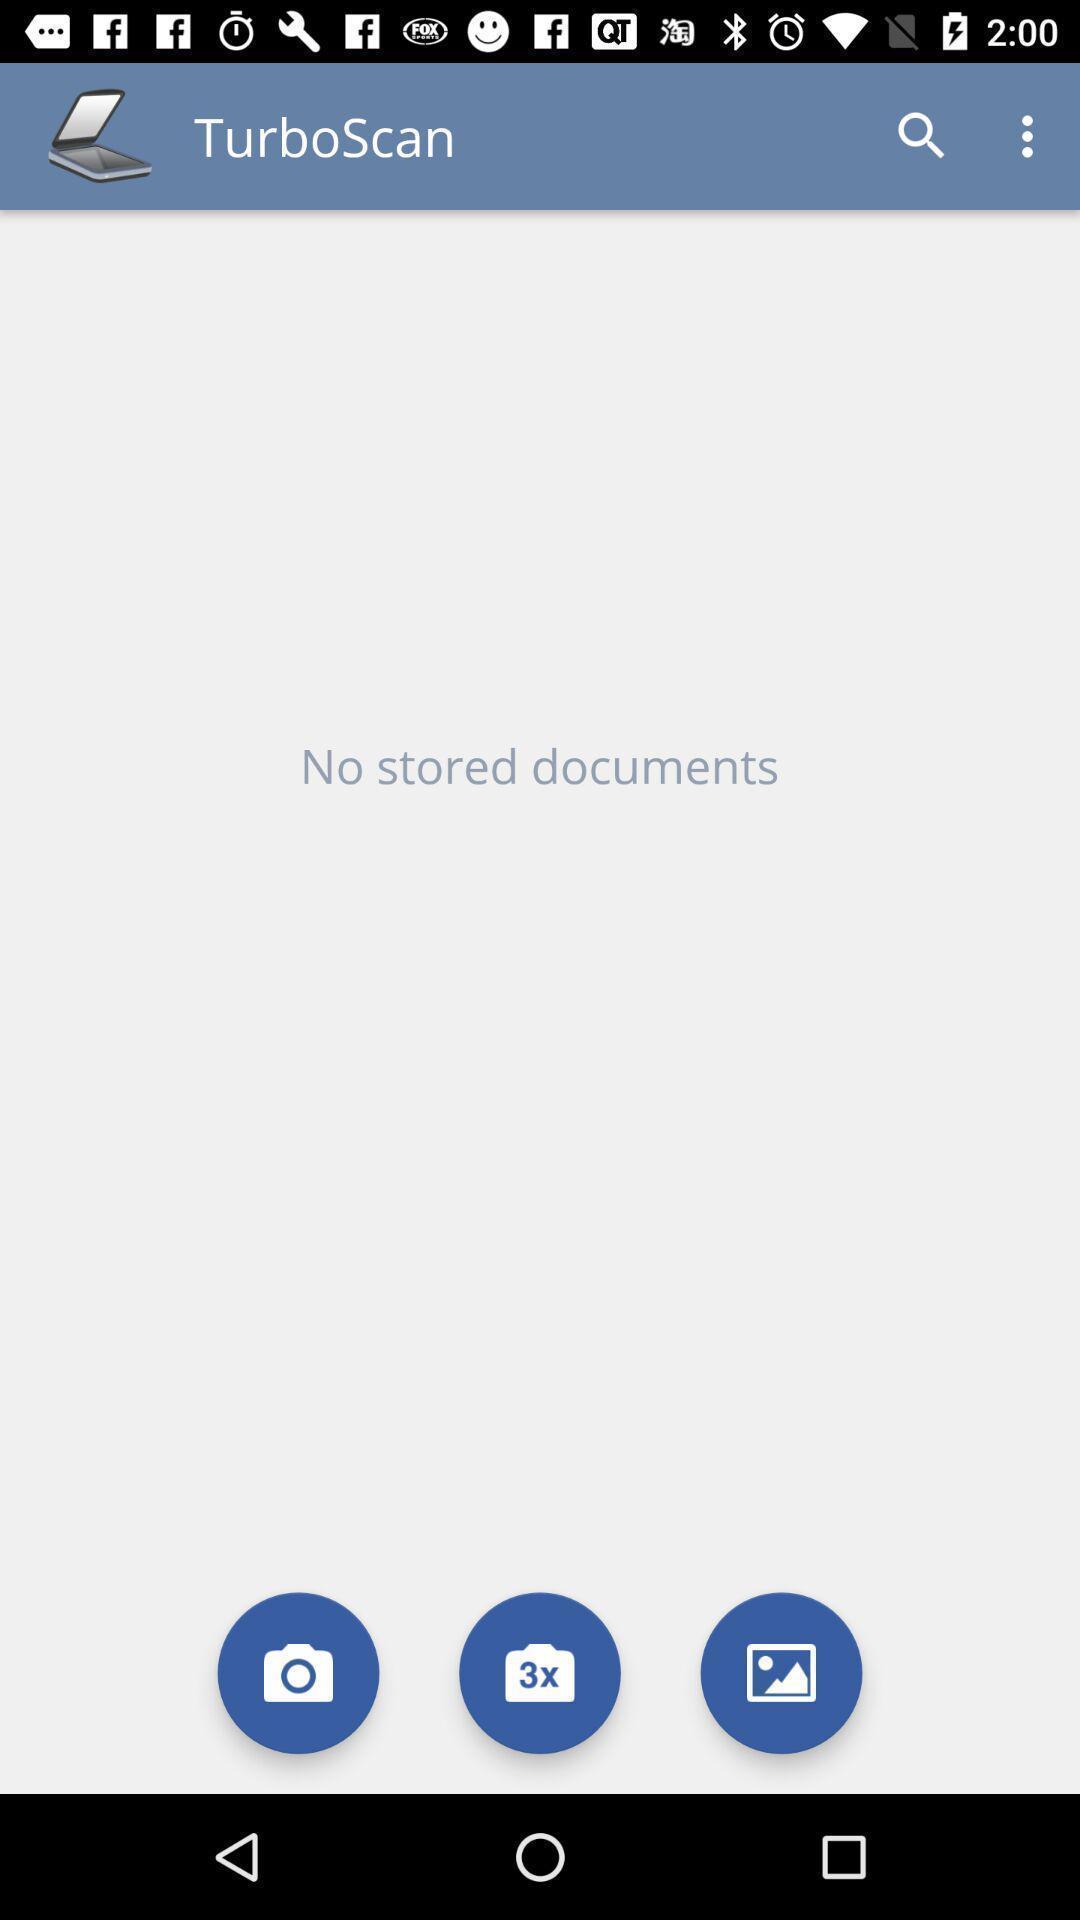Describe the key features of this screenshot. Screen displaying screen page. 